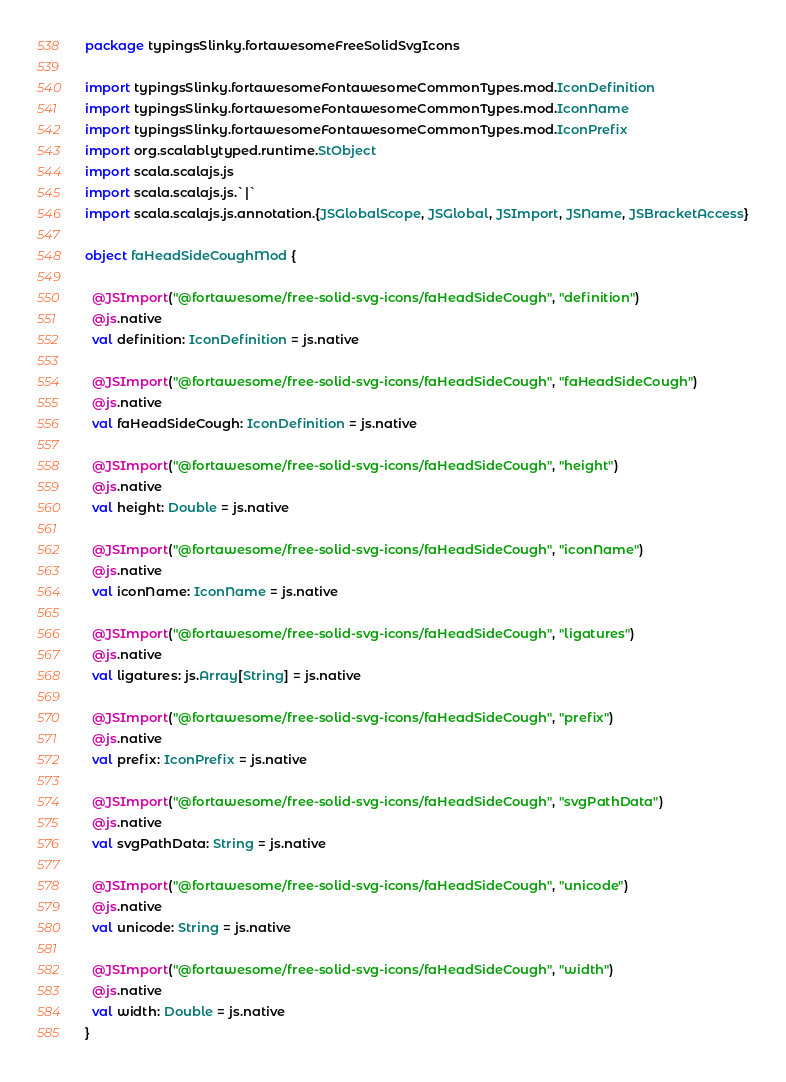<code> <loc_0><loc_0><loc_500><loc_500><_Scala_>package typingsSlinky.fortawesomeFreeSolidSvgIcons

import typingsSlinky.fortawesomeFontawesomeCommonTypes.mod.IconDefinition
import typingsSlinky.fortawesomeFontawesomeCommonTypes.mod.IconName
import typingsSlinky.fortawesomeFontawesomeCommonTypes.mod.IconPrefix
import org.scalablytyped.runtime.StObject
import scala.scalajs.js
import scala.scalajs.js.`|`
import scala.scalajs.js.annotation.{JSGlobalScope, JSGlobal, JSImport, JSName, JSBracketAccess}

object faHeadSideCoughMod {
  
  @JSImport("@fortawesome/free-solid-svg-icons/faHeadSideCough", "definition")
  @js.native
  val definition: IconDefinition = js.native
  
  @JSImport("@fortawesome/free-solid-svg-icons/faHeadSideCough", "faHeadSideCough")
  @js.native
  val faHeadSideCough: IconDefinition = js.native
  
  @JSImport("@fortawesome/free-solid-svg-icons/faHeadSideCough", "height")
  @js.native
  val height: Double = js.native
  
  @JSImport("@fortawesome/free-solid-svg-icons/faHeadSideCough", "iconName")
  @js.native
  val iconName: IconName = js.native
  
  @JSImport("@fortawesome/free-solid-svg-icons/faHeadSideCough", "ligatures")
  @js.native
  val ligatures: js.Array[String] = js.native
  
  @JSImport("@fortawesome/free-solid-svg-icons/faHeadSideCough", "prefix")
  @js.native
  val prefix: IconPrefix = js.native
  
  @JSImport("@fortawesome/free-solid-svg-icons/faHeadSideCough", "svgPathData")
  @js.native
  val svgPathData: String = js.native
  
  @JSImport("@fortawesome/free-solid-svg-icons/faHeadSideCough", "unicode")
  @js.native
  val unicode: String = js.native
  
  @JSImport("@fortawesome/free-solid-svg-icons/faHeadSideCough", "width")
  @js.native
  val width: Double = js.native
}
</code> 